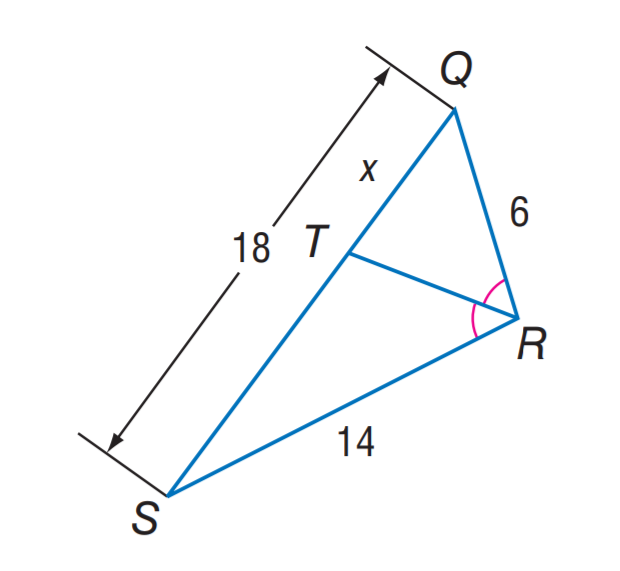Answer the mathemtical geometry problem and directly provide the correct option letter.
Question: Find x.
Choices: A: 2.7 B: 5.4 C: 6 D: 9 B 